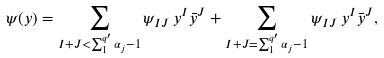<formula> <loc_0><loc_0><loc_500><loc_500>\psi ( y ) = \sum _ { I + J < \sum _ { 1 } ^ { q ^ { \prime } } \alpha _ { j } - { 1 } } \psi _ { I J } \, y ^ { I } \bar { y } ^ { J } + \sum _ { I + J = \sum _ { 1 } ^ { q ^ { \prime } } \alpha _ { j } - { 1 } } \psi _ { I J } \, y ^ { I } \bar { y } ^ { J } ,</formula> 